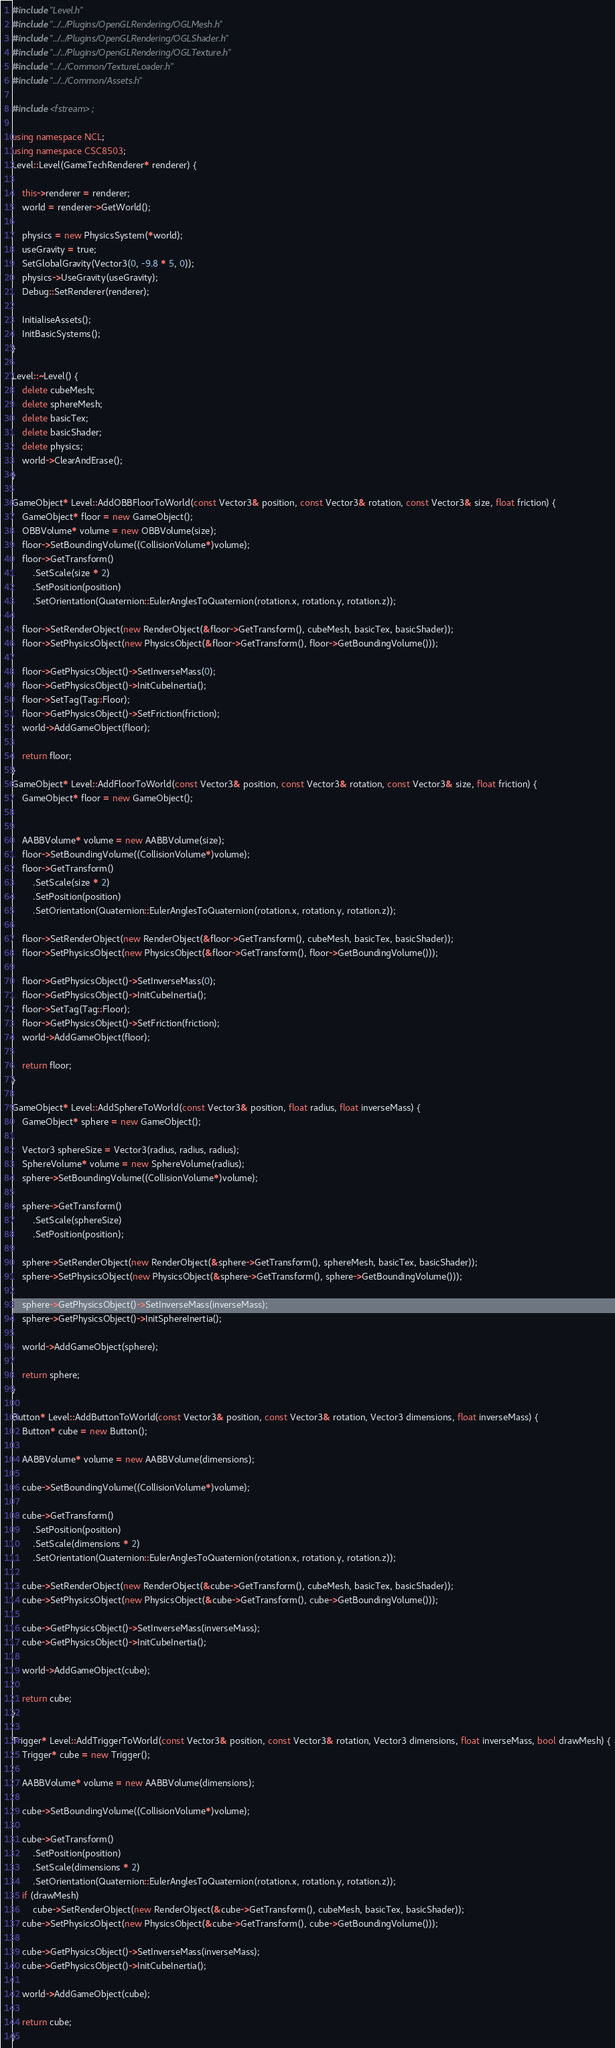Convert code to text. <code><loc_0><loc_0><loc_500><loc_500><_C++_>#include "Level.h"
#include "../../Plugins/OpenGLRendering/OGLMesh.h"
#include "../../Plugins/OpenGLRendering/OGLShader.h"
#include "../../Plugins/OpenGLRendering/OGLTexture.h"
#include "../../Common/TextureLoader.h"
#include "../../Common/Assets.h"

#include <fstream>;

using namespace NCL;
using namespace CSC8503;
Level::Level(GameTechRenderer* renderer) {
	
	this->renderer = renderer;
	world = renderer->GetWorld();
	
	physics = new PhysicsSystem(*world);
	useGravity = true;
	SetGlobalGravity(Vector3(0, -9.8 * 5, 0));
	physics->UseGravity(useGravity);
	Debug::SetRenderer(renderer);

	InitialiseAssets();
	InitBasicSystems();
}

Level::~Level() {
	delete cubeMesh;
	delete sphereMesh;
	delete basicTex;
	delete basicShader;
	delete physics;
	world->ClearAndErase();
}

GameObject* Level::AddOBBFloorToWorld(const Vector3& position, const Vector3& rotation, const Vector3& size, float friction) {
	GameObject* floor = new GameObject();
	OBBVolume* volume = new OBBVolume(size);
	floor->SetBoundingVolume((CollisionVolume*)volume);
	floor->GetTransform()
		.SetScale(size * 2)
		.SetPosition(position)
		.SetOrientation(Quaternion::EulerAnglesToQuaternion(rotation.x, rotation.y, rotation.z));

	floor->SetRenderObject(new RenderObject(&floor->GetTransform(), cubeMesh, basicTex, basicShader));
	floor->SetPhysicsObject(new PhysicsObject(&floor->GetTransform(), floor->GetBoundingVolume()));

	floor->GetPhysicsObject()->SetInverseMass(0);
	floor->GetPhysicsObject()->InitCubeInertia();
	floor->SetTag(Tag::Floor);
	floor->GetPhysicsObject()->SetFriction(friction);
	world->AddGameObject(floor);

	return floor;
}
GameObject* Level::AddFloorToWorld(const Vector3& position, const Vector3& rotation, const Vector3& size, float friction) {
	GameObject* floor = new GameObject();


	AABBVolume* volume = new AABBVolume(size);
	floor->SetBoundingVolume((CollisionVolume*)volume);
	floor->GetTransform()
		.SetScale(size * 2)
		.SetPosition(position)
		.SetOrientation(Quaternion::EulerAnglesToQuaternion(rotation.x, rotation.y, rotation.z));

	floor->SetRenderObject(new RenderObject(&floor->GetTransform(), cubeMesh, basicTex, basicShader));
	floor->SetPhysicsObject(new PhysicsObject(&floor->GetTransform(), floor->GetBoundingVolume()));

	floor->GetPhysicsObject()->SetInverseMass(0);
	floor->GetPhysicsObject()->InitCubeInertia();
	floor->SetTag(Tag::Floor);
	floor->GetPhysicsObject()->SetFriction(friction);
	world->AddGameObject(floor);

	return floor;
}

GameObject* Level::AddSphereToWorld(const Vector3& position, float radius, float inverseMass) {
	GameObject* sphere = new GameObject();

	Vector3 sphereSize = Vector3(radius, radius, radius);
	SphereVolume* volume = new SphereVolume(radius);
	sphere->SetBoundingVolume((CollisionVolume*)volume);

	sphere->GetTransform()
		.SetScale(sphereSize)
		.SetPosition(position);

	sphere->SetRenderObject(new RenderObject(&sphere->GetTransform(), sphereMesh, basicTex, basicShader));
	sphere->SetPhysicsObject(new PhysicsObject(&sphere->GetTransform(), sphere->GetBoundingVolume()));

	sphere->GetPhysicsObject()->SetInverseMass(inverseMass);
	sphere->GetPhysicsObject()->InitSphereInertia();

	world->AddGameObject(sphere);

	return sphere;
}

Button* Level::AddButtonToWorld(const Vector3& position, const Vector3& rotation, Vector3 dimensions, float inverseMass) {
	Button* cube = new Button();

	AABBVolume* volume = new AABBVolume(dimensions);

	cube->SetBoundingVolume((CollisionVolume*)volume);

	cube->GetTransform()
		.SetPosition(position)
		.SetScale(dimensions * 2)
		.SetOrientation(Quaternion::EulerAnglesToQuaternion(rotation.x, rotation.y, rotation.z));

	cube->SetRenderObject(new RenderObject(&cube->GetTransform(), cubeMesh, basicTex, basicShader));
	cube->SetPhysicsObject(new PhysicsObject(&cube->GetTransform(), cube->GetBoundingVolume()));

	cube->GetPhysicsObject()->SetInverseMass(inverseMass);
	cube->GetPhysicsObject()->InitCubeInertia();

	world->AddGameObject(cube);

	return cube;
}

Trigger* Level::AddTriggerToWorld(const Vector3& position, const Vector3& rotation, Vector3 dimensions, float inverseMass, bool drawMesh) {
	Trigger* cube = new Trigger();

	AABBVolume* volume = new AABBVolume(dimensions);

	cube->SetBoundingVolume((CollisionVolume*)volume);

	cube->GetTransform()
		.SetPosition(position)
		.SetScale(dimensions * 2)
		.SetOrientation(Quaternion::EulerAnglesToQuaternion(rotation.x, rotation.y, rotation.z));
	if (drawMesh)
		cube->SetRenderObject(new RenderObject(&cube->GetTransform(), cubeMesh, basicTex, basicShader));
	cube->SetPhysicsObject(new PhysicsObject(&cube->GetTransform(), cube->GetBoundingVolume()));

	cube->GetPhysicsObject()->SetInverseMass(inverseMass);
	cube->GetPhysicsObject()->InitCubeInertia();

	world->AddGameObject(cube);

	return cube;
}
</code> 